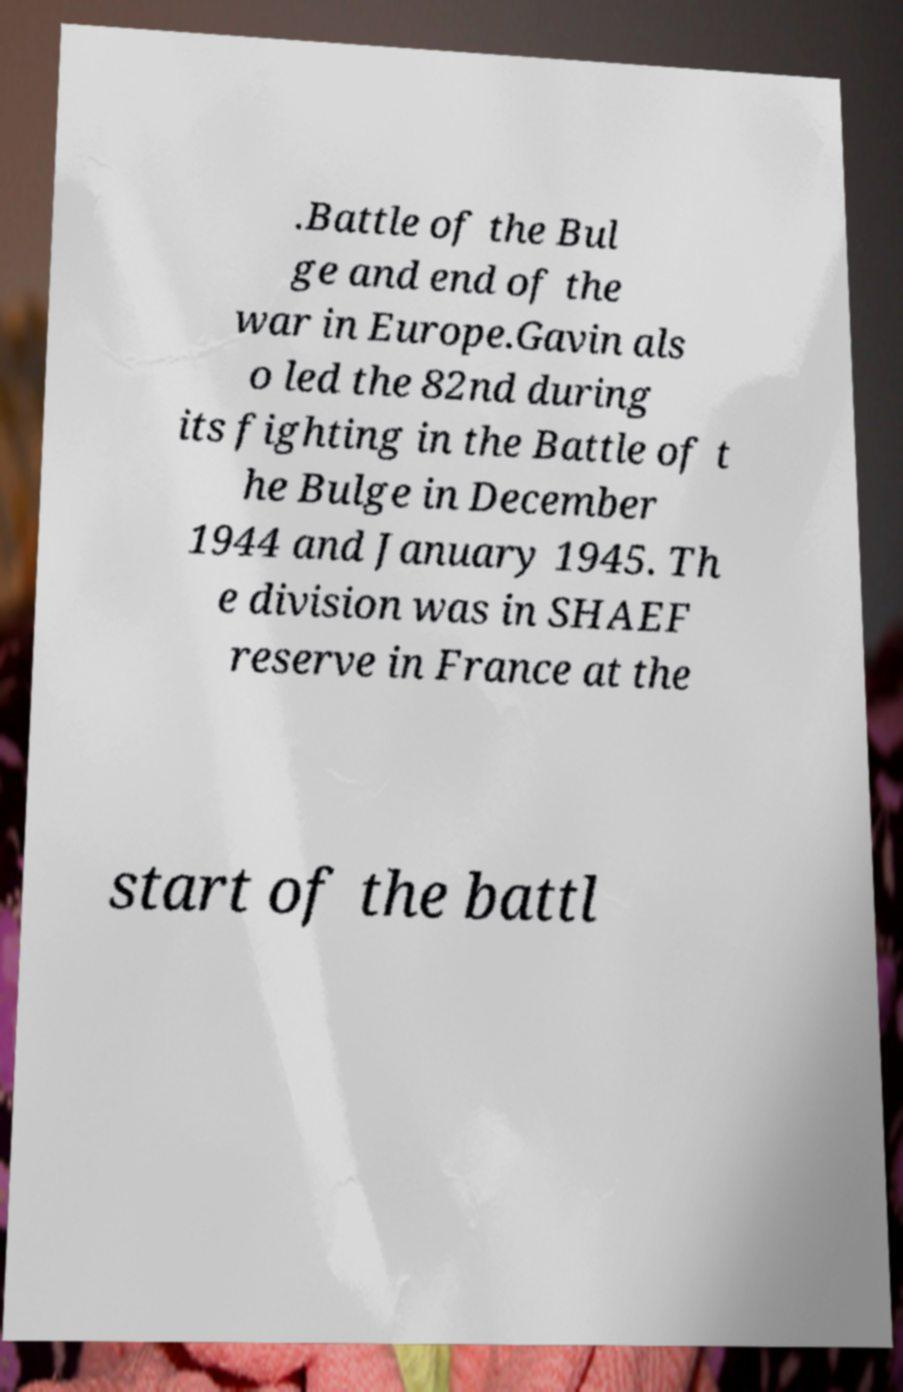Can you read and provide the text displayed in the image?This photo seems to have some interesting text. Can you extract and type it out for me? .Battle of the Bul ge and end of the war in Europe.Gavin als o led the 82nd during its fighting in the Battle of t he Bulge in December 1944 and January 1945. Th e division was in SHAEF reserve in France at the start of the battl 